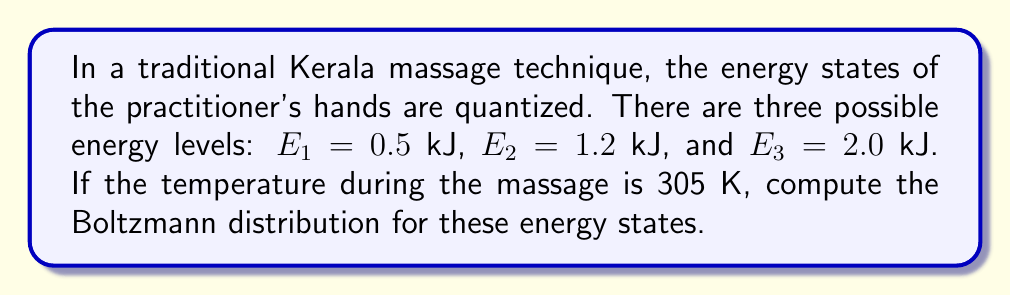Provide a solution to this math problem. To compute the Boltzmann distribution, we follow these steps:

1) The Boltzmann distribution is given by:
   $$P_i = \frac{e^{-E_i/kT}}{Z}$$
   where $P_i$ is the probability of the system being in state $i$, $E_i$ is the energy of state $i$, $k$ is the Boltzmann constant, $T$ is the temperature, and $Z$ is the partition function.

2) First, we need to calculate the partition function $Z$:
   $$Z = \sum_{i} e^{-E_i/kT}$$

3) We know that $k = 1.380649 \times 10^{-23}$ J/K, and $T = 305$ K. Let's convert our energies to Joules:
   $E_1 = 500$ J, $E_2 = 1200$ J, $E_3 = 2000$ J

4) Now we can calculate $Z$:
   $$Z = e^{-500/(1.380649 \times 10^{-23} \times 305)} + e^{-1200/(1.380649 \times 10^{-23} \times 305)} + e^{-2000/(1.380649 \times 10^{-23} \times 305)}$$
   $$Z \approx e^{-119.1} + e^{-285.9} + e^{-476.5} \approx 1.0 \times 10^{-52} + 2.8 \times 10^{-124} + 1.7 \times 10^{-207} \approx 1.0 \times 10^{-52}$$

5) Now we can calculate the probabilities:
   $$P_1 = \frac{e^{-119.1}}{1.0 \times 10^{-52}} \approx 1.0$$
   $$P_2 = \frac{e^{-285.9}}{1.0 \times 10^{-52}} \approx 2.8 \times 10^{-72}$$
   $$P_3 = \frac{e^{-476.5}}{1.0 \times 10^{-52}} \approx 1.7 \times 10^{-155}$$
Answer: $P_1 \approx 1.0$, $P_2 \approx 2.8 \times 10^{-72}$, $P_3 \approx 1.7 \times 10^{-155}$ 